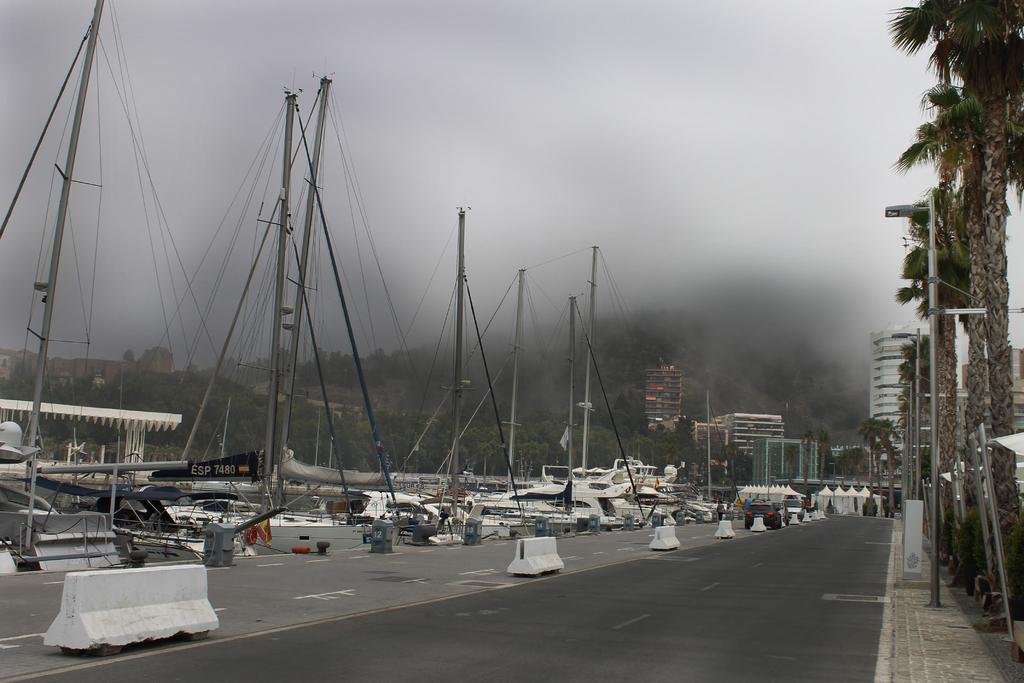Please provide a concise description of this image. This picture is clicked outside the city. At the bottom, we see the road and the stoppers. On the left side, we see the yachts, boats and the trees. On the right side, we see the poles, street lights and the trees. There are trees and buildings in the background. At the top, we see the sky. 